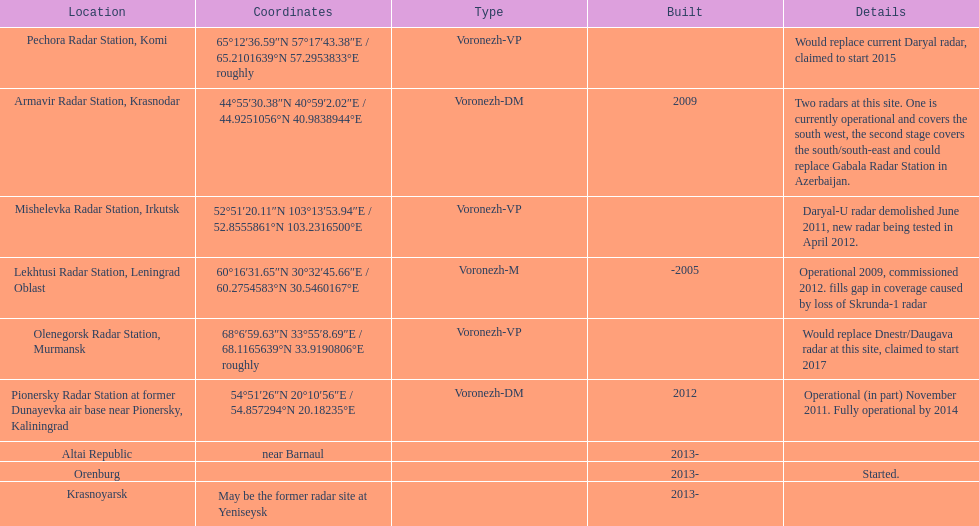How long did it take the pionersky radar station to go from partially operational to fully operational? 3 years. 